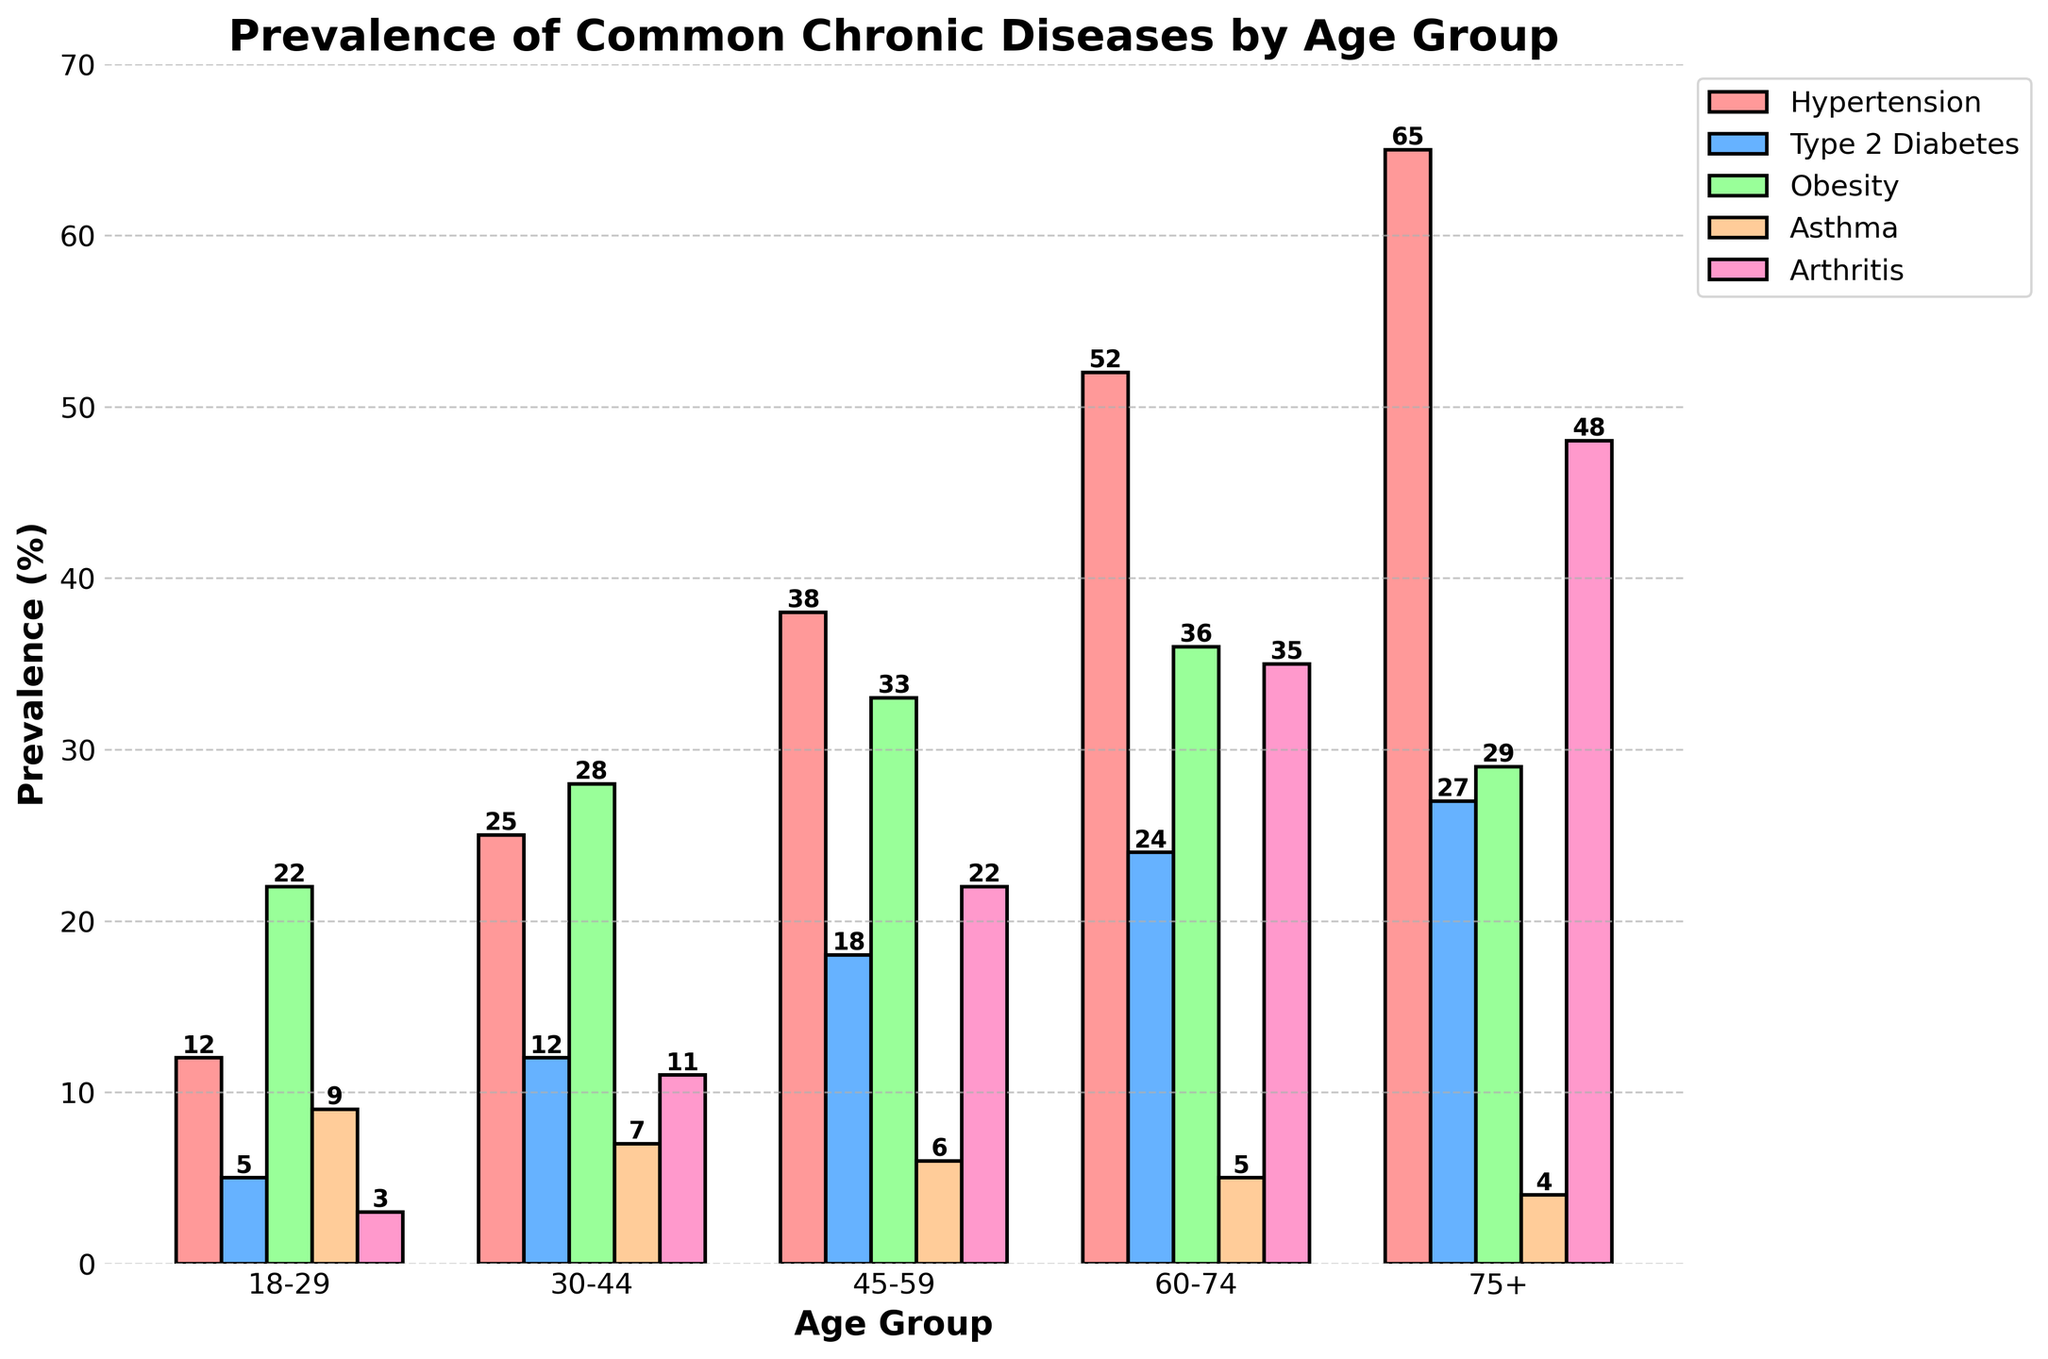What age group has the highest prevalence of hypertension? By looking at the figure, identify the age group with the tallest bar for hypertension (typically marked in red). Compare the heights of bars for each age group to identify the highest one.
Answer: 75+ Which age group has the lowest prevalence of asthma? By observing the figure, find the age group with the shortest bar for asthma (typically marked in orange). Compare the heights of bars for asthma across all age groups to identify the lowest one.
Answer: 75+ What is the difference in the prevalence of Type 2 Diabetes between the 45-59 age group and the 18-29 age group? Compare the height of the bar representing Type 2 Diabetes in the 45-59 age group to the bar in the 18-29 age group, then find the difference. Type 2 Diabetes is typically marked in blue. 18 and 5, difference is 18 - 5 = 13
Answer: 13 Which disease has the highest prevalence in the 60-74 age group? Look at the figure and identify the tallest bar among Hypertension, Type 2 Diabetes, Obesity, Asthma, and Arthritis in the 60-74 age group. The labels and corresponding bar heights help determine the disease.
Answer: Hypertension What is the average prevalence of obesity across all age groups? Sum the prevalence percentages of obesity for all age groups and divide by the number of age groups. The prevalence values are 22, 28, 33, 36, and 29. Sum is 148, number of age groups is 5, so 148/5.
Answer: 29.6 Which two diseases have the closest prevalence in the 75+ age group? Compare the bar heights in the 75+ age group to find which two diseases have the most similar values. Compare Hypertension, Type 2 Diabetes, Obesity, Asthma, and Arthritis. Hypertension is 65, Type 2 Diabetes is 27, Obesity is 29, Asthma is 4, Arthritis is 48. The closest values are Type 2 Diabetes (27) and Obesity (29).
Answer: Type 2 Diabetes and Obesity Between Hypertension and Arthritis, which has a higher increase in prevalence from the 18-29 age group to the 75+ age group? Calculate the difference in prevalence for both Hypertension and Arthritis from the 18-29 age group to 75+ age group. Hypertension increases from 12 to 65 (difference 65-12 = 53), Arthritis increases from 3 to 48 (difference 48-3 = 45). Compare the differences.
Answer: Hypertension What are the median values of prevalence for Hypertension and Obesity? Arrange the prevalence values in ascending order for both Hypertension and Obesity. The middle value in each sorted list is the median.
Hypertension prevalence: 12, 25, 38, 52, 65 → Median is 38.
Obesity prevalence: 22, 28, 29, 33, 36 → Median is 29.
Answer: Hypertension: 38, Obesity: 29 Which age group shows the most uniform prevalence across all diseases, and what evidence supports this? Compare the height differences between bars for all diseases within each age group. Identify the age group where the heights (prevalence percentages) of the bars are most similar, indicating the uniformity. The 18-29 age group shows relatively small differences in bar heights (12, 5, 22, 9, 3), compared to other age groups where differences are larger.
Answer: 18-29 